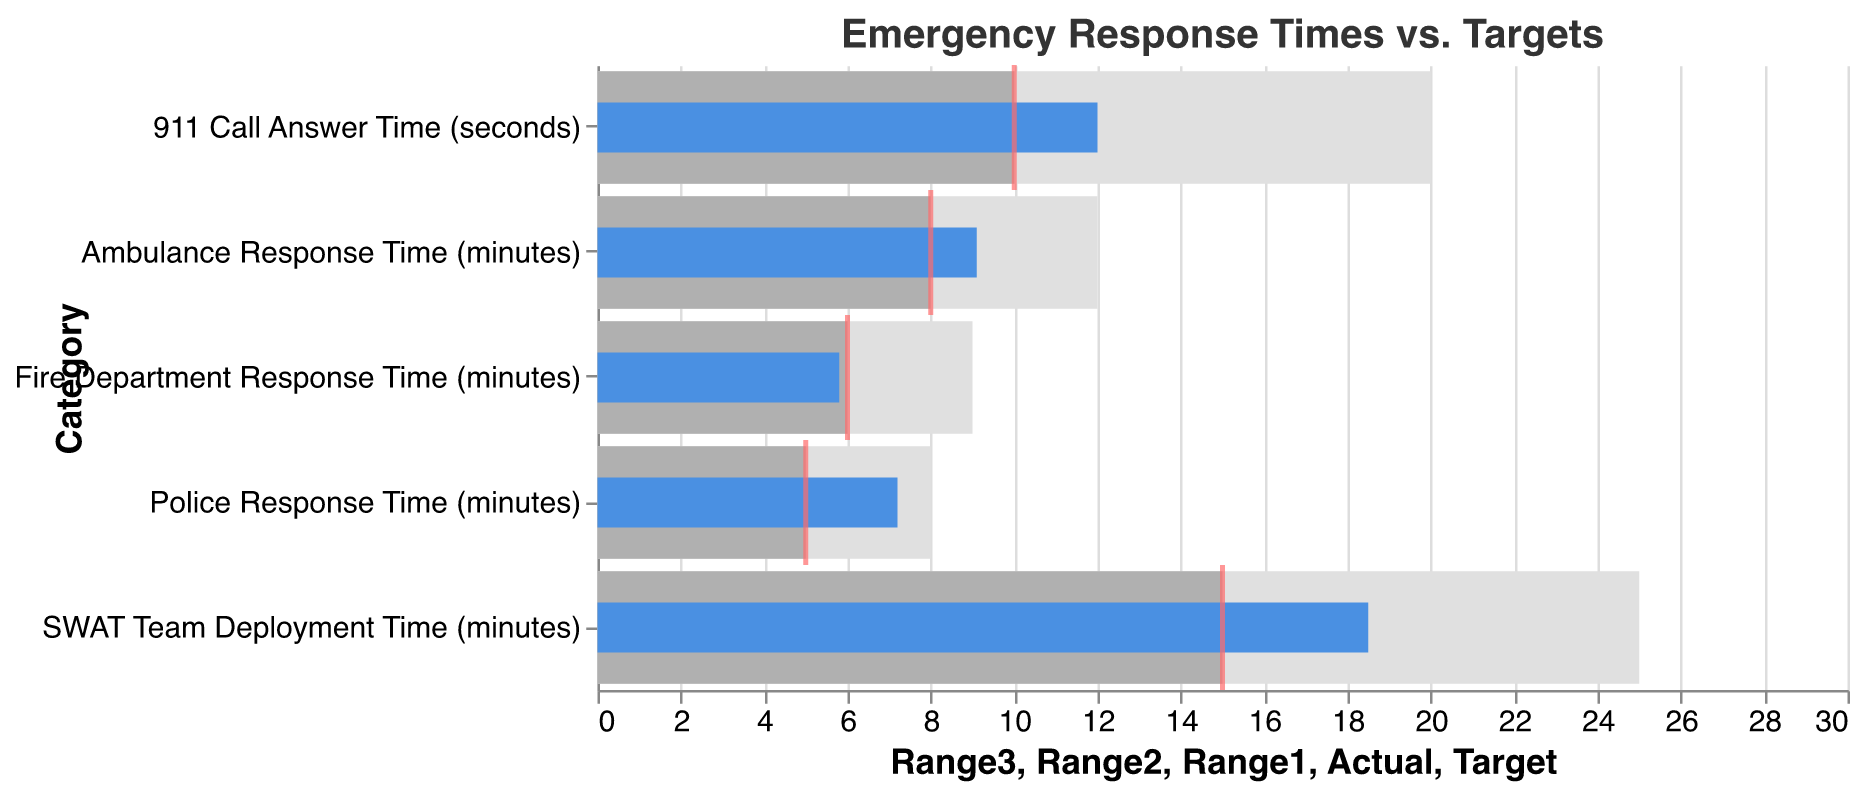What's the title of the chart? The title of the chart is displayed at the top of the figure.
Answer: Emergency Response Times vs. Targets Which emergency response category has the largest discrepancy between actual and target times? To find the largest discrepancy, look at each category's actual and target times. Calculate the differences: Police: 7.2 - 5 = 2.2; Fire: 5.8 - 6 = -0.2; Ambulance: 9.1 - 8 = 1.1; 911 Call: 12 - 10 = 2; SWAT: 18.5 - 15 = 3.5. The largest difference is for SWAT Team Deployment Time.
Answer: SWAT Team Deployment Time Are any of the actual response times within the optimal range? The optimal range is represented by the lightest color bar (Range1). Check each category's actual time against its Range1 upper limit: Police: 7.2 > 5, Fire: 5.8 ≤ 6, Ambulance: 9.1 > 8, 911 Call: 12 > 10, SWAT: 18.5 > 15. Only the Fire Department Response Time is within its optimal range.
Answer: Fire Department Response Time How does the actual 911 call answer time compare to its target? Look at the actual and target times for 911 Call Answer Time: Actual = 12 seconds and Target = 10 seconds. Actual time is greater than the target time by 2 seconds.
Answer: 2 seconds slower What percentage above the target is the Ambulance Response Time? Calculate the percentage increase: (Actual - Target) / Target * 100. For Ambulance Response: (9.1 - 8) / 8 * 100 = 1.1 / 8 * 100 = 13.75%.
Answer: 13.75% Which categories have an actual time that is worse than their target time? Compare the actual time to the target time for each category: Police: 7.2 > 5, Fire: 5.8 < 6, Ambulance: 9.1 > 8, 911 Call: 12 > 10, SWAT: 18.5 > 15. The categories are Police, Ambulance, 911 Call, and SWAT.
Answer: Police, Ambulance, 911 Call, SWAT How does the actual Police Response Time compare to the start of its acceptable range? The Police acceptable range starts at 5 minutes. The actual Police Response Time is 7.2 minutes, which is 2.2 minutes above the start of the acceptable range.
Answer: 2.2 minutes above What is the typical acceptable range for the Fire Department Response Time? The acceptable range is represented by the Range2 bar, which extends up to its value: The Fire Department acceptable range is up to 6 minutes.
Answer: Up to 6 minutes In terms of percentage, which category's actual time exceeds its target by the greatest margin? Calculate the percentage increase for each category: Police: (7.2 - 5) / 5 * 100 = 44%; Fire: (5.8 - 6) / 6 * 100 = -3.3%; Ambulance: (9.1 - 8) / 8 * 100 = 13.75%; 911 Call: (12 - 10) / 10 * 100 = 20%; SWAT: (18.5 - 15) / 15 * 100 = 23.33%. The highest percentage over target is for Police Response Time.
Answer: Police Response Time, 44% 